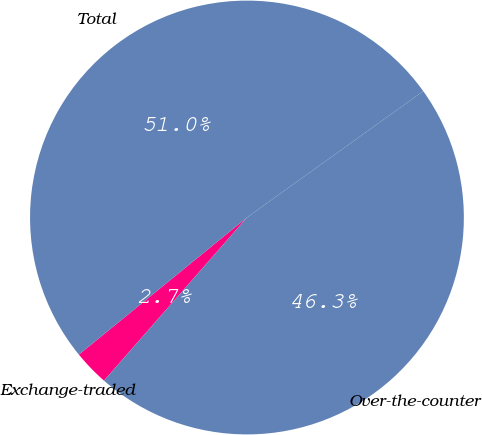Convert chart. <chart><loc_0><loc_0><loc_500><loc_500><pie_chart><fcel>Exchange-traded<fcel>Over-the-counter<fcel>Total<nl><fcel>2.66%<fcel>46.35%<fcel>50.99%<nl></chart> 